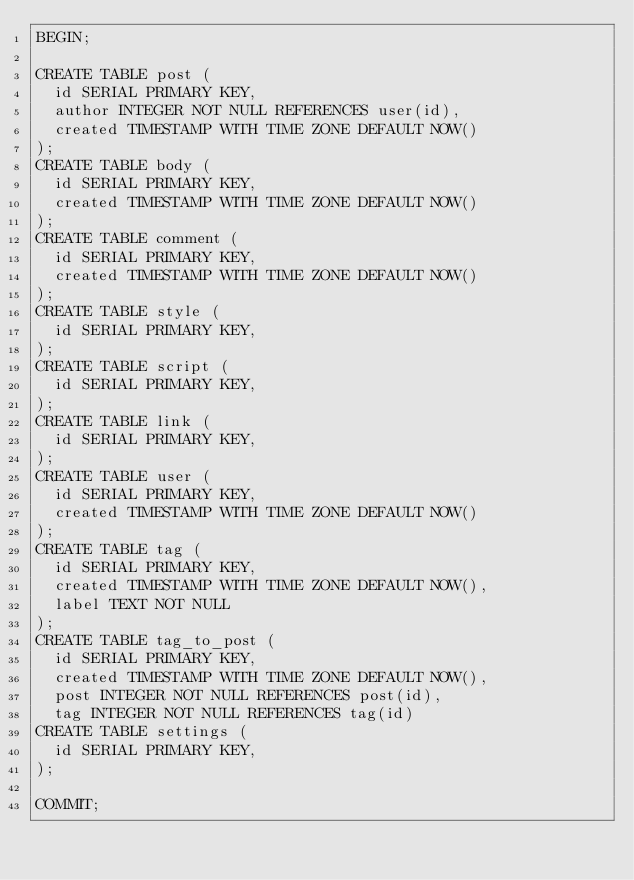<code> <loc_0><loc_0><loc_500><loc_500><_SQL_>BEGIN;

CREATE TABLE post (
  id SERIAL PRIMARY KEY,
  author INTEGER NOT NULL REFERENCES user(id),
  created TIMESTAMP WITH TIME ZONE DEFAULT NOW()
);
CREATE TABLE body (
  id SERIAL PRIMARY KEY,
  created TIMESTAMP WITH TIME ZONE DEFAULT NOW()
);
CREATE TABLE comment (
  id SERIAL PRIMARY KEY,
  created TIMESTAMP WITH TIME ZONE DEFAULT NOW()
);
CREATE TABLE style (
  id SERIAL PRIMARY KEY,
);
CREATE TABLE script (
  id SERIAL PRIMARY KEY,
);
CREATE TABLE link (
  id SERIAL PRIMARY KEY,
);
CREATE TABLE user (
  id SERIAL PRIMARY KEY,
  created TIMESTAMP WITH TIME ZONE DEFAULT NOW()
);
CREATE TABLE tag (
  id SERIAL PRIMARY KEY,
  created TIMESTAMP WITH TIME ZONE DEFAULT NOW(),
  label TEXT NOT NULL
);
CREATE TABLE tag_to_post (
  id SERIAL PRIMARY KEY,
  created TIMESTAMP WITH TIME ZONE DEFAULT NOW(),
  post INTEGER NOT NULL REFERENCES post(id),
  tag INTEGER NOT NULL REFERENCES tag(id)
CREATE TABLE settings (
  id SERIAL PRIMARY KEY,
);

COMMIT;
</code> 